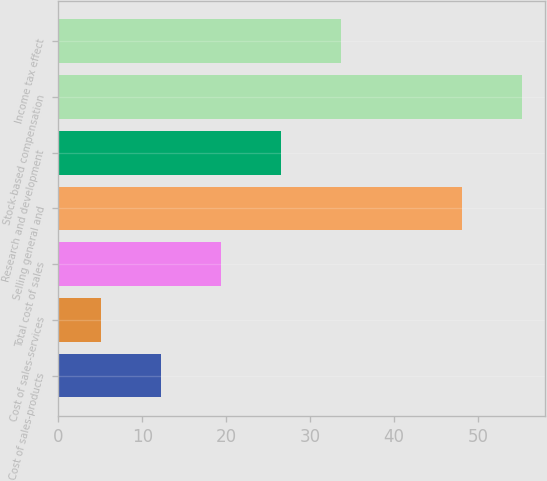Convert chart to OTSL. <chart><loc_0><loc_0><loc_500><loc_500><bar_chart><fcel>Cost of sales-products<fcel>Cost of sales-services<fcel>Total cost of sales<fcel>Selling general and<fcel>Research and development<fcel>Stock-based compensation<fcel>Income tax effect<nl><fcel>12.25<fcel>5.1<fcel>19.4<fcel>48.1<fcel>26.55<fcel>55.25<fcel>33.7<nl></chart> 